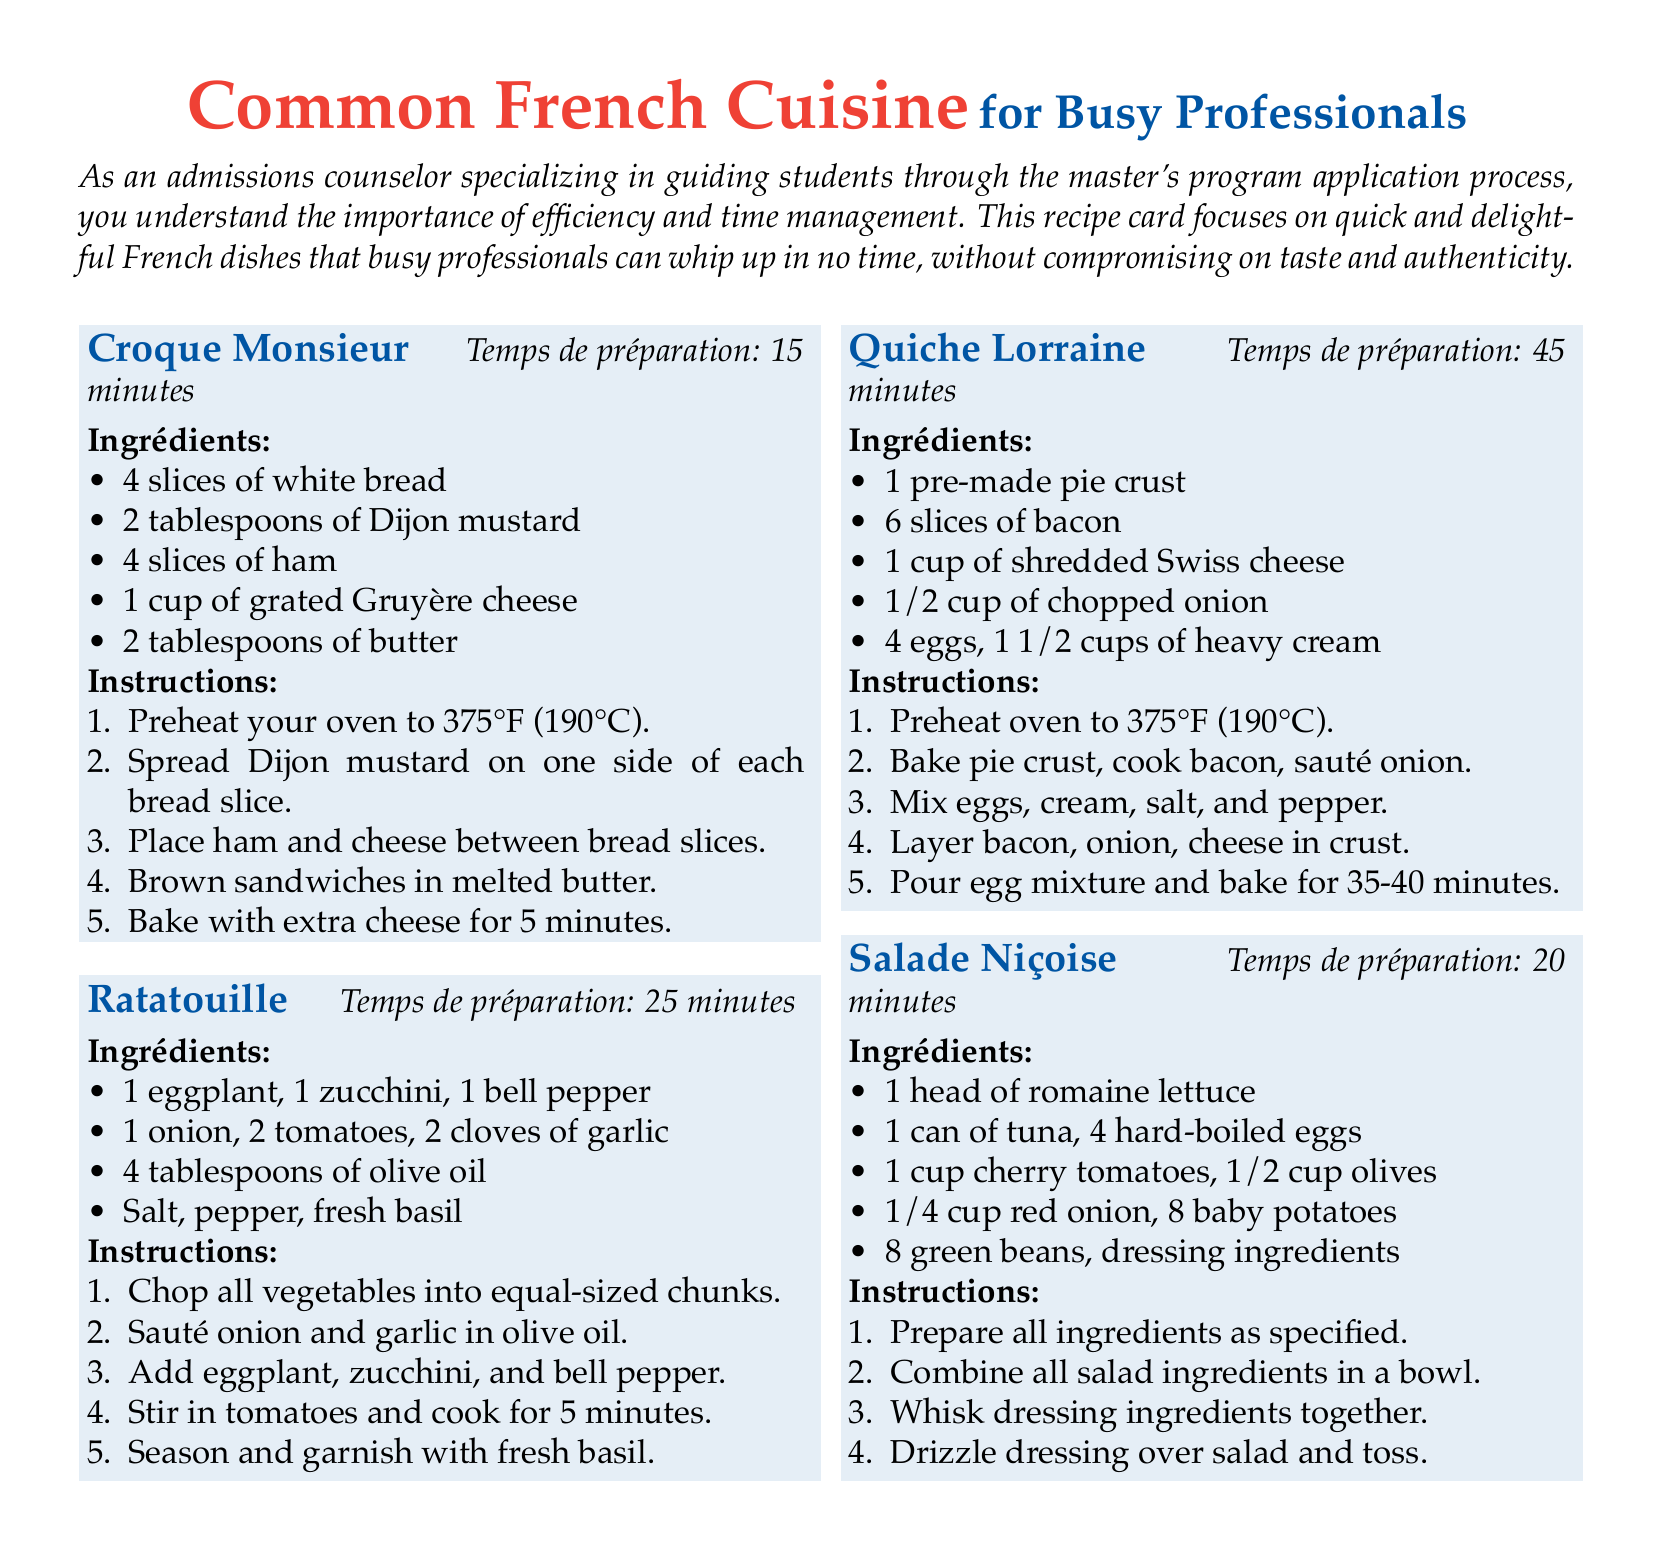What is the preparation time for Croque Monsieur? The preparation time for Croque Monsieur is stated in the recipe section.
Answer: 15 minutes How many slices of bacon are needed for Quiche Lorraine? The recipe for Quiche Lorraine specifies the amount of bacon required.
Answer: 6 slices What is the main vegetable used in Ratatouille? Ratatouille includes various vegetables, but the primary one can be identified through the ingredient list.
Answer: Eggplant How many eggs are used in the Salade Niçoise? The recipe specifies the number of hard-boiled eggs needed for the dish.
Answer: 4 hard-boiled eggs Which cheese is used in Croque Monsieur? The type of cheese needed for Croque Monsieur is listed in the ingredients.
Answer: Gruyère cheese What is the cooking time for Quiche Lorraine? The total cooking time for Quiche Lorraine is detailed in the recipe.
Answer: 35-40 minutes How many types of salad ingredients need to be prepared for Salade Niçoise? The list of ingredients provided indicates how many items are included in the salad.
Answer: 8 What is the color theme of the recipe card? The document uses specific colors that contribute to its design theme, identifiable from the text.
Answer: French blue and French red What cooking technique is primarily used for the vegetables in Ratatouille? The recipe mentions how the vegetables are prepared, indicating the technique used.
Answer: Sauté 